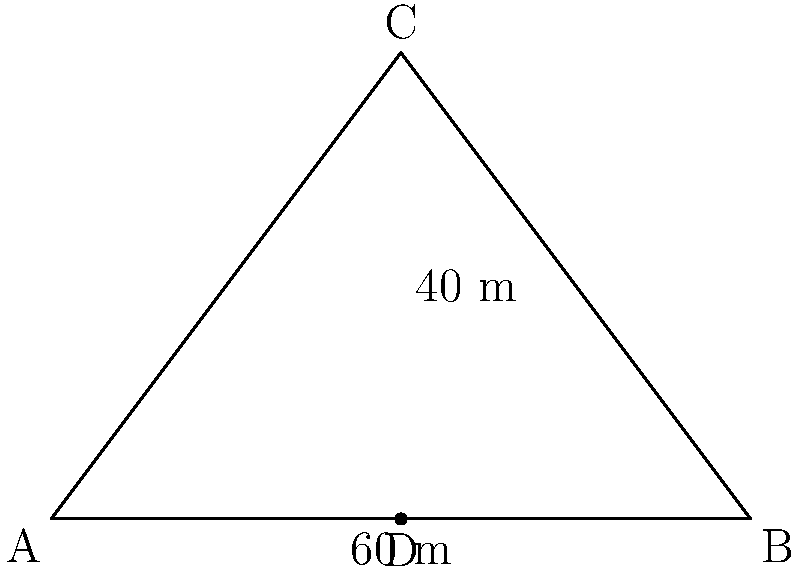As part of a new development project in Stockton-on-Tees, you need to report on a triangular plot of land. The plot has a base of 60 meters and a height of 40 meters. What is the area of this triangular plot in square meters? To calculate the area of a triangular plot, we can use the formula:

$$\text{Area} = \frac{1}{2} \times \text{base} \times \text{height}$$

Given:
- Base of the triangle = 60 meters
- Height of the triangle = 40 meters

Let's substitute these values into the formula:

$$\begin{align}
\text{Area} &= \frac{1}{2} \times 60 \times 40 \\[6pt]
&= \frac{1}{2} \times 2400 \\[6pt]
&= 1200
\end{align}$$

Therefore, the area of the triangular plot is 1200 square meters.
Answer: 1200 m² 